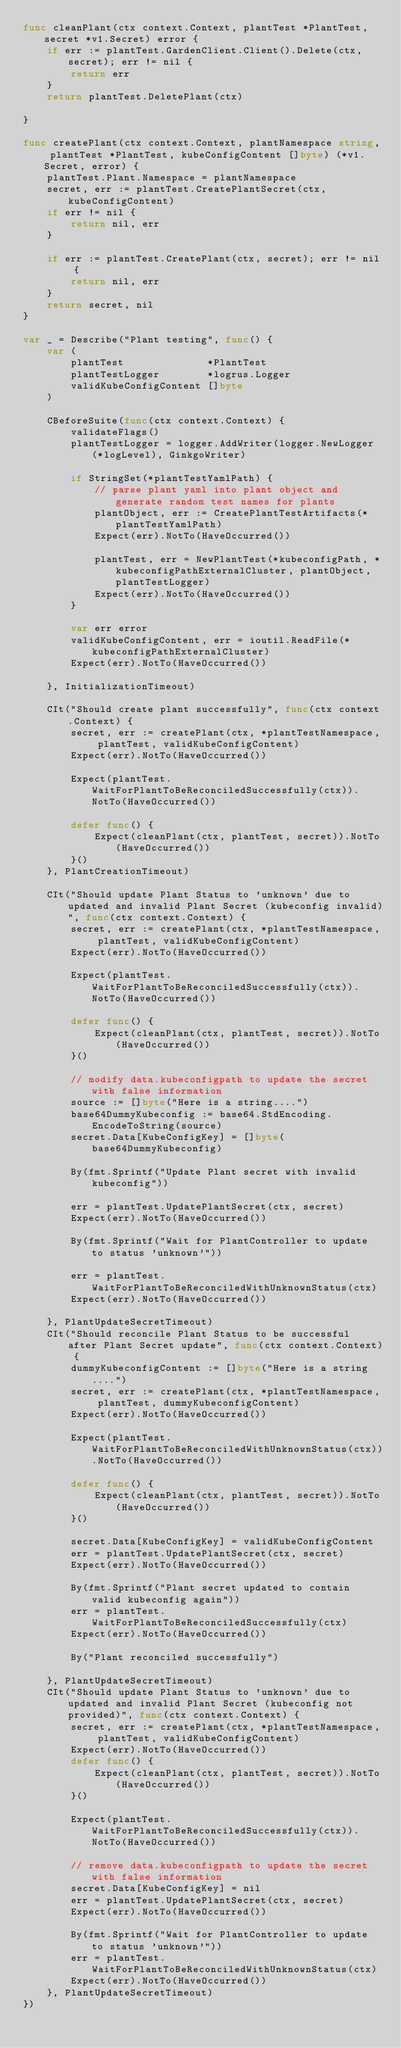Convert code to text. <code><loc_0><loc_0><loc_500><loc_500><_Go_>func cleanPlant(ctx context.Context, plantTest *PlantTest, secret *v1.Secret) error {
	if err := plantTest.GardenClient.Client().Delete(ctx, secret); err != nil {
		return err
	}
	return plantTest.DeletePlant(ctx)

}

func createPlant(ctx context.Context, plantNamespace string, plantTest *PlantTest, kubeConfigContent []byte) (*v1.Secret, error) {
	plantTest.Plant.Namespace = plantNamespace
	secret, err := plantTest.CreatePlantSecret(ctx, kubeConfigContent)
	if err != nil {
		return nil, err
	}

	if err := plantTest.CreatePlant(ctx, secret); err != nil {
		return nil, err
	}
	return secret, nil
}

var _ = Describe("Plant testing", func() {
	var (
		plantTest              *PlantTest
		plantTestLogger        *logrus.Logger
		validKubeConfigContent []byte
	)

	CBeforeSuite(func(ctx context.Context) {
		validateFlags()
		plantTestLogger = logger.AddWriter(logger.NewLogger(*logLevel), GinkgoWriter)

		if StringSet(*plantTestYamlPath) {
			// parse plant yaml into plant object and generate random test names for plants
			plantObject, err := CreatePlantTestArtifacts(*plantTestYamlPath)
			Expect(err).NotTo(HaveOccurred())

			plantTest, err = NewPlantTest(*kubeconfigPath, *kubeconfigPathExternalCluster, plantObject, plantTestLogger)
			Expect(err).NotTo(HaveOccurred())
		}

		var err error
		validKubeConfigContent, err = ioutil.ReadFile(*kubeconfigPathExternalCluster)
		Expect(err).NotTo(HaveOccurred())

	}, InitializationTimeout)

	CIt("Should create plant successfully", func(ctx context.Context) {
		secret, err := createPlant(ctx, *plantTestNamespace, plantTest, validKubeConfigContent)
		Expect(err).NotTo(HaveOccurred())

		Expect(plantTest.WaitForPlantToBeReconciledSuccessfully(ctx)).NotTo(HaveOccurred())

		defer func() {
			Expect(cleanPlant(ctx, plantTest, secret)).NotTo(HaveOccurred())
		}()
	}, PlantCreationTimeout)

	CIt("Should update Plant Status to 'unknown' due to updated and invalid Plant Secret (kubeconfig invalid)", func(ctx context.Context) {
		secret, err := createPlant(ctx, *plantTestNamespace, plantTest, validKubeConfigContent)
		Expect(err).NotTo(HaveOccurred())

		Expect(plantTest.WaitForPlantToBeReconciledSuccessfully(ctx)).NotTo(HaveOccurred())

		defer func() {
			Expect(cleanPlant(ctx, plantTest, secret)).NotTo(HaveOccurred())
		}()

		// modify data.kubeconfigpath to update the secret with false information
		source := []byte("Here is a string....")
		base64DummyKubeconfig := base64.StdEncoding.EncodeToString(source)
		secret.Data[KubeConfigKey] = []byte(base64DummyKubeconfig)

		By(fmt.Sprintf("Update Plant secret with invalid kubeconfig"))

		err = plantTest.UpdatePlantSecret(ctx, secret)
		Expect(err).NotTo(HaveOccurred())

		By(fmt.Sprintf("Wait for PlantController to update to status 'unknown'"))

		err = plantTest.WaitForPlantToBeReconciledWithUnknownStatus(ctx)
		Expect(err).NotTo(HaveOccurred())

	}, PlantUpdateSecretTimeout)
	CIt("Should reconcile Plant Status to be successful after Plant Secret update", func(ctx context.Context) {
		dummyKubeconfigContent := []byte("Here is a string....")
		secret, err := createPlant(ctx, *plantTestNamespace, plantTest, dummyKubeconfigContent)
		Expect(err).NotTo(HaveOccurred())

		Expect(plantTest.WaitForPlantToBeReconciledWithUnknownStatus(ctx)).NotTo(HaveOccurred())

		defer func() {
			Expect(cleanPlant(ctx, plantTest, secret)).NotTo(HaveOccurred())
		}()

		secret.Data[KubeConfigKey] = validKubeConfigContent
		err = plantTest.UpdatePlantSecret(ctx, secret)
		Expect(err).NotTo(HaveOccurred())

		By(fmt.Sprintf("Plant secret updated to contain valid kubeconfig again"))
		err = plantTest.WaitForPlantToBeReconciledSuccessfully(ctx)
		Expect(err).NotTo(HaveOccurred())

		By("Plant reconciled successfully")

	}, PlantUpdateSecretTimeout)
	CIt("Should update Plant Status to 'unknown' due to updated and invalid Plant Secret (kubeconfig not provided)", func(ctx context.Context) {
		secret, err := createPlant(ctx, *plantTestNamespace, plantTest, validKubeConfigContent)
		Expect(err).NotTo(HaveOccurred())
		defer func() {
			Expect(cleanPlant(ctx, plantTest, secret)).NotTo(HaveOccurred())
		}()

		Expect(plantTest.WaitForPlantToBeReconciledSuccessfully(ctx)).NotTo(HaveOccurred())

		// remove data.kubeconfigpath to update the secret with false information
		secret.Data[KubeConfigKey] = nil
		err = plantTest.UpdatePlantSecret(ctx, secret)
		Expect(err).NotTo(HaveOccurred())

		By(fmt.Sprintf("Wait for PlantController to update to status 'unknown'"))
		err = plantTest.WaitForPlantToBeReconciledWithUnknownStatus(ctx)
		Expect(err).NotTo(HaveOccurred())
	}, PlantUpdateSecretTimeout)
})
</code> 